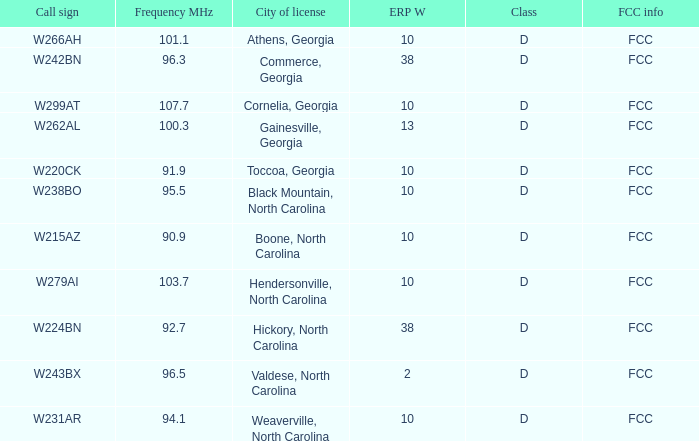For station w262al, what is the fcc frequency when its frequency mhz is more than 92.7? FCC. 